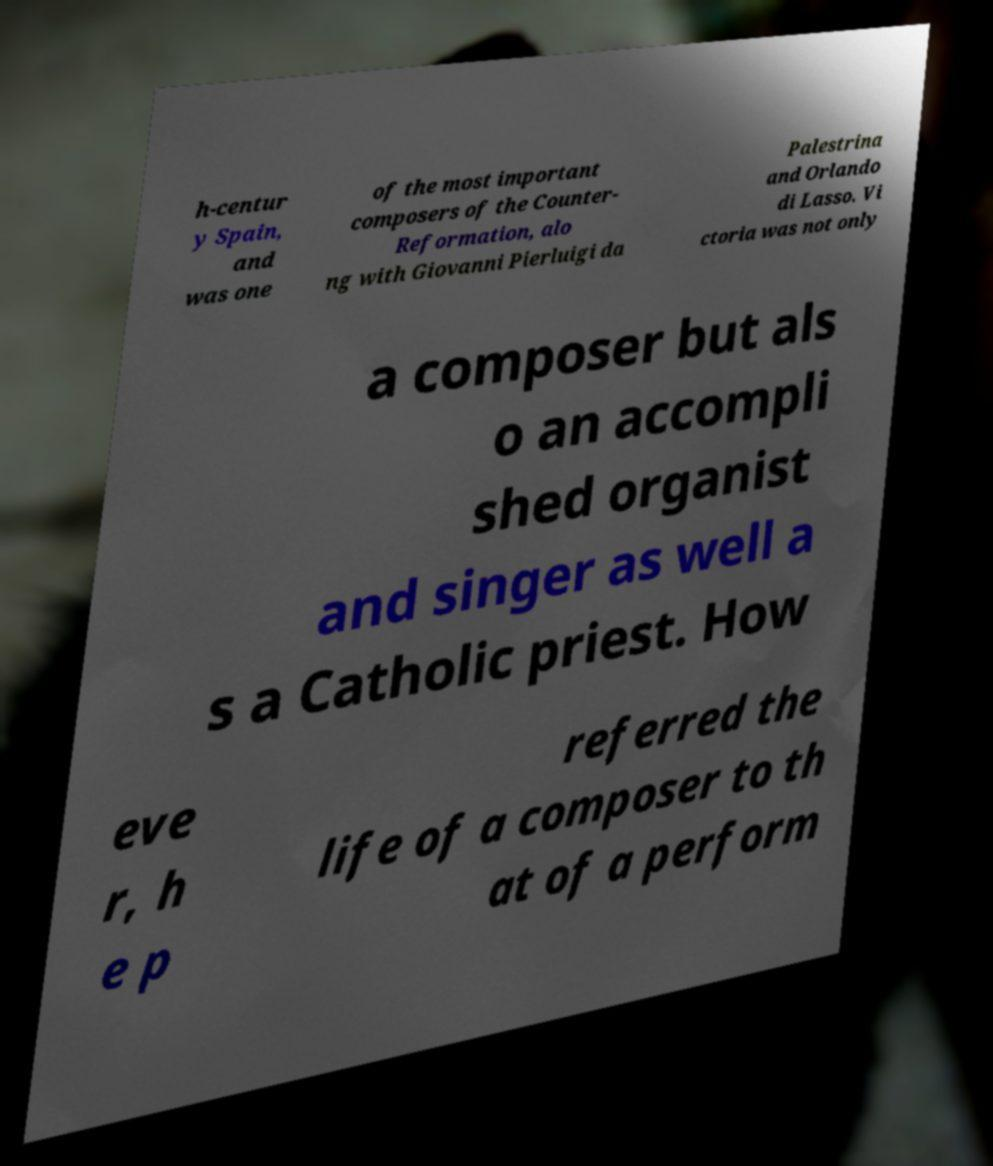What messages or text are displayed in this image? I need them in a readable, typed format. h-centur y Spain, and was one of the most important composers of the Counter- Reformation, alo ng with Giovanni Pierluigi da Palestrina and Orlando di Lasso. Vi ctoria was not only a composer but als o an accompli shed organist and singer as well a s a Catholic priest. How eve r, h e p referred the life of a composer to th at of a perform 